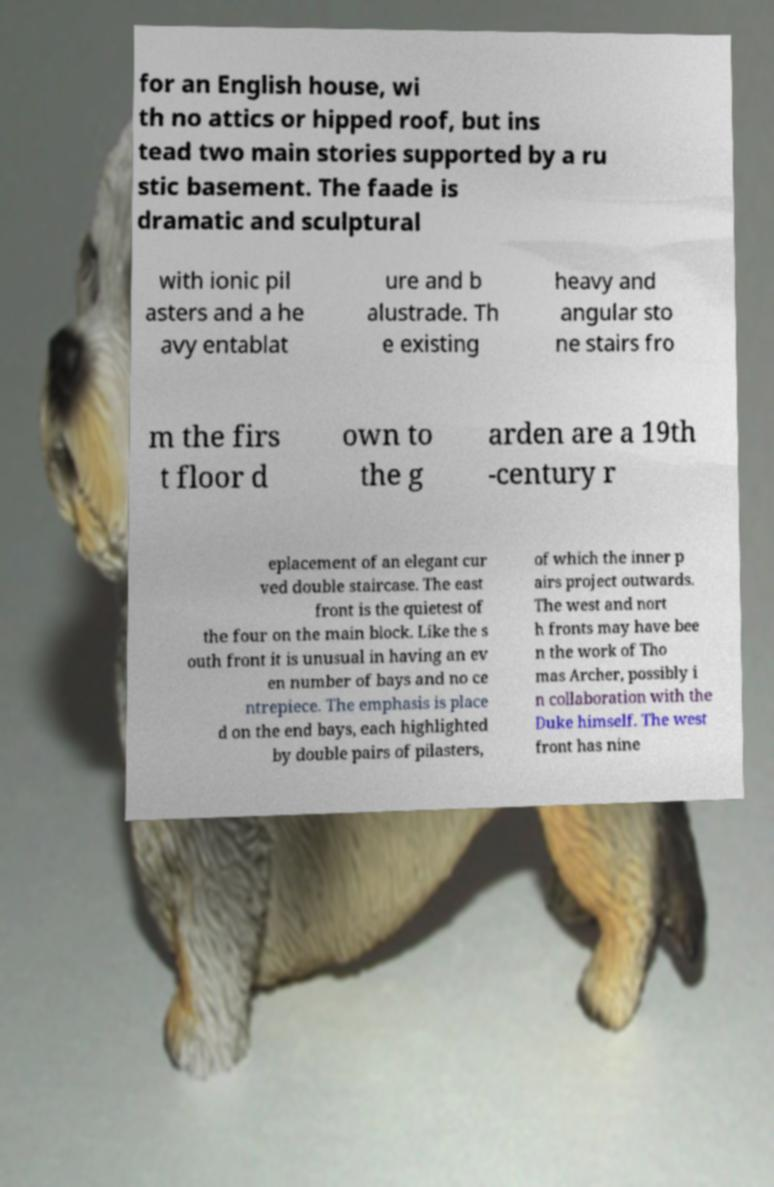Could you extract and type out the text from this image? for an English house, wi th no attics or hipped roof, but ins tead two main stories supported by a ru stic basement. The faade is dramatic and sculptural with ionic pil asters and a he avy entablat ure and b alustrade. Th e existing heavy and angular sto ne stairs fro m the firs t floor d own to the g arden are a 19th -century r eplacement of an elegant cur ved double staircase. The east front is the quietest of the four on the main block. Like the s outh front it is unusual in having an ev en number of bays and no ce ntrepiece. The emphasis is place d on the end bays, each highlighted by double pairs of pilasters, of which the inner p airs project outwards. The west and nort h fronts may have bee n the work of Tho mas Archer, possibly i n collaboration with the Duke himself. The west front has nine 